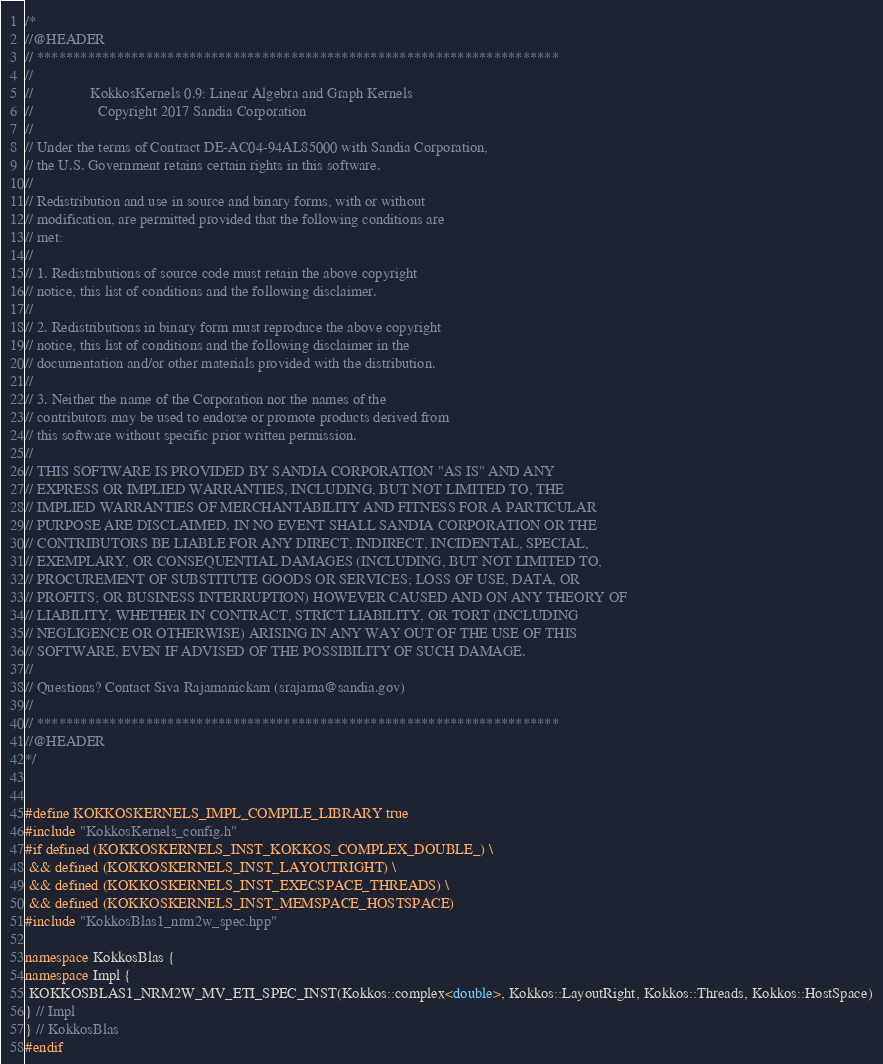<code> <loc_0><loc_0><loc_500><loc_500><_C++_>/*
//@HEADER
// ************************************************************************
//
//               KokkosKernels 0.9: Linear Algebra and Graph Kernels
//                 Copyright 2017 Sandia Corporation
//
// Under the terms of Contract DE-AC04-94AL85000 with Sandia Corporation,
// the U.S. Government retains certain rights in this software.
//
// Redistribution and use in source and binary forms, with or without
// modification, are permitted provided that the following conditions are
// met:
//
// 1. Redistributions of source code must retain the above copyright
// notice, this list of conditions and the following disclaimer.
//
// 2. Redistributions in binary form must reproduce the above copyright
// notice, this list of conditions and the following disclaimer in the
// documentation and/or other materials provided with the distribution.
//
// 3. Neither the name of the Corporation nor the names of the
// contributors may be used to endorse or promote products derived from
// this software without specific prior written permission.
//
// THIS SOFTWARE IS PROVIDED BY SANDIA CORPORATION "AS IS" AND ANY
// EXPRESS OR IMPLIED WARRANTIES, INCLUDING, BUT NOT LIMITED TO, THE
// IMPLIED WARRANTIES OF MERCHANTABILITY AND FITNESS FOR A PARTICULAR
// PURPOSE ARE DISCLAIMED. IN NO EVENT SHALL SANDIA CORPORATION OR THE
// CONTRIBUTORS BE LIABLE FOR ANY DIRECT, INDIRECT, INCIDENTAL, SPECIAL,
// EXEMPLARY, OR CONSEQUENTIAL DAMAGES (INCLUDING, BUT NOT LIMITED TO,
// PROCUREMENT OF SUBSTITUTE GOODS OR SERVICES; LOSS OF USE, DATA, OR
// PROFITS; OR BUSINESS INTERRUPTION) HOWEVER CAUSED AND ON ANY THEORY OF
// LIABILITY, WHETHER IN CONTRACT, STRICT LIABILITY, OR TORT (INCLUDING
// NEGLIGENCE OR OTHERWISE) ARISING IN ANY WAY OUT OF THE USE OF THIS
// SOFTWARE, EVEN IF ADVISED OF THE POSSIBILITY OF SUCH DAMAGE.
//
// Questions? Contact Siva Rajamanickam (srajama@sandia.gov)
//
// ************************************************************************
//@HEADER
*/


#define KOKKOSKERNELS_IMPL_COMPILE_LIBRARY true
#include "KokkosKernels_config.h"
#if defined (KOKKOSKERNELS_INST_KOKKOS_COMPLEX_DOUBLE_) \
 && defined (KOKKOSKERNELS_INST_LAYOUTRIGHT) \
 && defined (KOKKOSKERNELS_INST_EXECSPACE_THREADS) \
 && defined (KOKKOSKERNELS_INST_MEMSPACE_HOSTSPACE)
#include "KokkosBlas1_nrm2w_spec.hpp"

namespace KokkosBlas {
namespace Impl {
 KOKKOSBLAS1_NRM2W_MV_ETI_SPEC_INST(Kokkos::complex<double>, Kokkos::LayoutRight, Kokkos::Threads, Kokkos::HostSpace)
} // Impl
} // KokkosBlas
#endif
</code> 